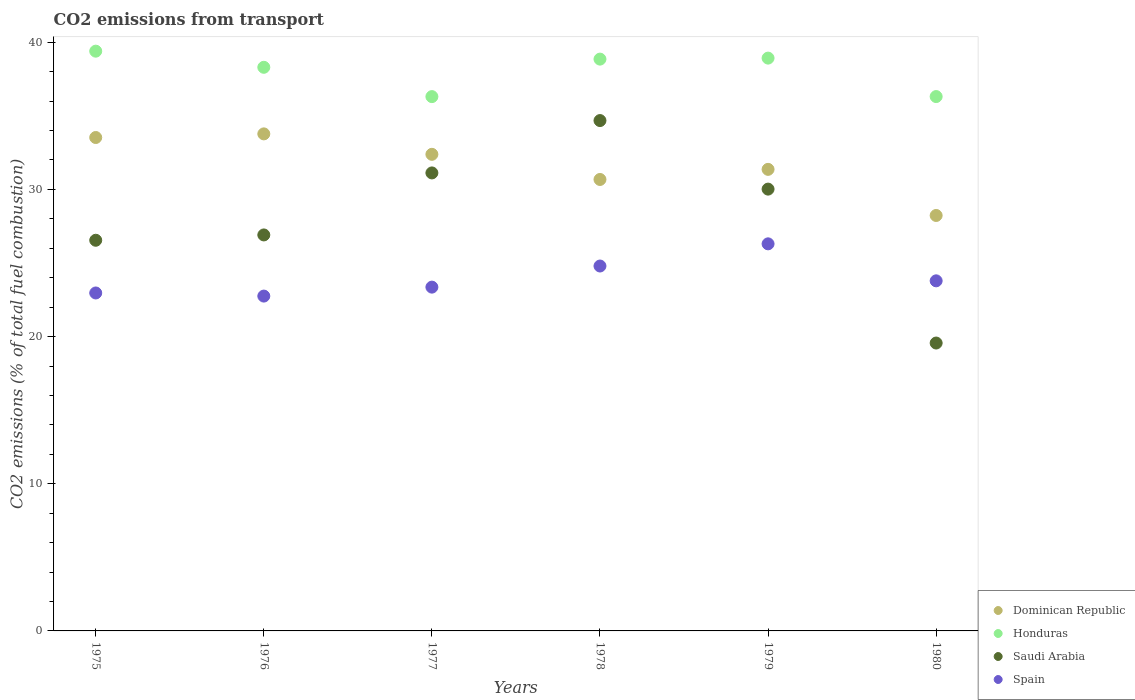How many different coloured dotlines are there?
Your response must be concise. 4. Is the number of dotlines equal to the number of legend labels?
Provide a succinct answer. Yes. What is the total CO2 emitted in Spain in 1975?
Provide a succinct answer. 22.96. Across all years, what is the maximum total CO2 emitted in Honduras?
Offer a very short reply. 39.39. Across all years, what is the minimum total CO2 emitted in Dominican Republic?
Ensure brevity in your answer.  28.23. In which year was the total CO2 emitted in Saudi Arabia maximum?
Offer a very short reply. 1978. In which year was the total CO2 emitted in Honduras minimum?
Provide a short and direct response. 1977. What is the total total CO2 emitted in Saudi Arabia in the graph?
Keep it short and to the point. 168.83. What is the difference between the total CO2 emitted in Honduras in 1976 and that in 1978?
Keep it short and to the point. -0.56. What is the difference between the total CO2 emitted in Honduras in 1980 and the total CO2 emitted in Saudi Arabia in 1977?
Your answer should be very brief. 5.19. What is the average total CO2 emitted in Spain per year?
Provide a succinct answer. 23.99. In the year 1979, what is the difference between the total CO2 emitted in Honduras and total CO2 emitted in Dominican Republic?
Your answer should be compact. 7.56. What is the ratio of the total CO2 emitted in Dominican Republic in 1975 to that in 1979?
Your response must be concise. 1.07. What is the difference between the highest and the second highest total CO2 emitted in Dominican Republic?
Make the answer very short. 0.25. What is the difference between the highest and the lowest total CO2 emitted in Honduras?
Offer a terse response. 3.09. Is it the case that in every year, the sum of the total CO2 emitted in Saudi Arabia and total CO2 emitted in Honduras  is greater than the total CO2 emitted in Dominican Republic?
Keep it short and to the point. Yes. Is the total CO2 emitted in Spain strictly greater than the total CO2 emitted in Dominican Republic over the years?
Give a very brief answer. No. Is the total CO2 emitted in Spain strictly less than the total CO2 emitted in Saudi Arabia over the years?
Keep it short and to the point. No. How many dotlines are there?
Your response must be concise. 4. How many years are there in the graph?
Your answer should be compact. 6. What is the difference between two consecutive major ticks on the Y-axis?
Give a very brief answer. 10. Are the values on the major ticks of Y-axis written in scientific E-notation?
Provide a short and direct response. No. Does the graph contain any zero values?
Your answer should be very brief. No. Does the graph contain grids?
Offer a terse response. No. Where does the legend appear in the graph?
Provide a short and direct response. Bottom right. How are the legend labels stacked?
Keep it short and to the point. Vertical. What is the title of the graph?
Keep it short and to the point. CO2 emissions from transport. Does "West Bank and Gaza" appear as one of the legend labels in the graph?
Offer a very short reply. No. What is the label or title of the X-axis?
Offer a very short reply. Years. What is the label or title of the Y-axis?
Provide a succinct answer. CO2 emissions (% of total fuel combustion). What is the CO2 emissions (% of total fuel combustion) in Dominican Republic in 1975?
Provide a short and direct response. 33.53. What is the CO2 emissions (% of total fuel combustion) of Honduras in 1975?
Offer a very short reply. 39.39. What is the CO2 emissions (% of total fuel combustion) of Saudi Arabia in 1975?
Offer a very short reply. 26.55. What is the CO2 emissions (% of total fuel combustion) in Spain in 1975?
Make the answer very short. 22.96. What is the CO2 emissions (% of total fuel combustion) of Dominican Republic in 1976?
Your answer should be compact. 33.77. What is the CO2 emissions (% of total fuel combustion) in Honduras in 1976?
Provide a succinct answer. 38.3. What is the CO2 emissions (% of total fuel combustion) in Saudi Arabia in 1976?
Offer a terse response. 26.91. What is the CO2 emissions (% of total fuel combustion) in Spain in 1976?
Offer a terse response. 22.75. What is the CO2 emissions (% of total fuel combustion) of Dominican Republic in 1977?
Make the answer very short. 32.38. What is the CO2 emissions (% of total fuel combustion) of Honduras in 1977?
Your response must be concise. 36.31. What is the CO2 emissions (% of total fuel combustion) of Saudi Arabia in 1977?
Your response must be concise. 31.12. What is the CO2 emissions (% of total fuel combustion) in Spain in 1977?
Give a very brief answer. 23.36. What is the CO2 emissions (% of total fuel combustion) of Dominican Republic in 1978?
Your response must be concise. 30.68. What is the CO2 emissions (% of total fuel combustion) in Honduras in 1978?
Keep it short and to the point. 38.85. What is the CO2 emissions (% of total fuel combustion) of Saudi Arabia in 1978?
Your answer should be very brief. 34.68. What is the CO2 emissions (% of total fuel combustion) of Spain in 1978?
Your answer should be compact. 24.8. What is the CO2 emissions (% of total fuel combustion) of Dominican Republic in 1979?
Provide a succinct answer. 31.36. What is the CO2 emissions (% of total fuel combustion) of Honduras in 1979?
Your response must be concise. 38.92. What is the CO2 emissions (% of total fuel combustion) of Saudi Arabia in 1979?
Your answer should be compact. 30.02. What is the CO2 emissions (% of total fuel combustion) of Spain in 1979?
Ensure brevity in your answer.  26.3. What is the CO2 emissions (% of total fuel combustion) of Dominican Republic in 1980?
Ensure brevity in your answer.  28.23. What is the CO2 emissions (% of total fuel combustion) in Honduras in 1980?
Keep it short and to the point. 36.31. What is the CO2 emissions (% of total fuel combustion) of Saudi Arabia in 1980?
Offer a very short reply. 19.56. What is the CO2 emissions (% of total fuel combustion) in Spain in 1980?
Your response must be concise. 23.79. Across all years, what is the maximum CO2 emissions (% of total fuel combustion) in Dominican Republic?
Provide a short and direct response. 33.77. Across all years, what is the maximum CO2 emissions (% of total fuel combustion) of Honduras?
Keep it short and to the point. 39.39. Across all years, what is the maximum CO2 emissions (% of total fuel combustion) in Saudi Arabia?
Give a very brief answer. 34.68. Across all years, what is the maximum CO2 emissions (% of total fuel combustion) in Spain?
Provide a short and direct response. 26.3. Across all years, what is the minimum CO2 emissions (% of total fuel combustion) of Dominican Republic?
Ensure brevity in your answer.  28.23. Across all years, what is the minimum CO2 emissions (% of total fuel combustion) of Honduras?
Your answer should be very brief. 36.31. Across all years, what is the minimum CO2 emissions (% of total fuel combustion) of Saudi Arabia?
Your answer should be compact. 19.56. Across all years, what is the minimum CO2 emissions (% of total fuel combustion) in Spain?
Your answer should be compact. 22.75. What is the total CO2 emissions (% of total fuel combustion) in Dominican Republic in the graph?
Provide a succinct answer. 189.95. What is the total CO2 emissions (% of total fuel combustion) in Honduras in the graph?
Offer a very short reply. 228.08. What is the total CO2 emissions (% of total fuel combustion) in Saudi Arabia in the graph?
Ensure brevity in your answer.  168.83. What is the total CO2 emissions (% of total fuel combustion) of Spain in the graph?
Your response must be concise. 143.96. What is the difference between the CO2 emissions (% of total fuel combustion) in Dominican Republic in 1975 and that in 1976?
Your answer should be very brief. -0.25. What is the difference between the CO2 emissions (% of total fuel combustion) in Honduras in 1975 and that in 1976?
Ensure brevity in your answer.  1.1. What is the difference between the CO2 emissions (% of total fuel combustion) in Saudi Arabia in 1975 and that in 1976?
Make the answer very short. -0.36. What is the difference between the CO2 emissions (% of total fuel combustion) in Spain in 1975 and that in 1976?
Offer a very short reply. 0.21. What is the difference between the CO2 emissions (% of total fuel combustion) in Dominican Republic in 1975 and that in 1977?
Your answer should be very brief. 1.14. What is the difference between the CO2 emissions (% of total fuel combustion) of Honduras in 1975 and that in 1977?
Provide a succinct answer. 3.09. What is the difference between the CO2 emissions (% of total fuel combustion) of Saudi Arabia in 1975 and that in 1977?
Give a very brief answer. -4.58. What is the difference between the CO2 emissions (% of total fuel combustion) of Spain in 1975 and that in 1977?
Provide a short and direct response. -0.4. What is the difference between the CO2 emissions (% of total fuel combustion) in Dominican Republic in 1975 and that in 1978?
Keep it short and to the point. 2.85. What is the difference between the CO2 emissions (% of total fuel combustion) of Honduras in 1975 and that in 1978?
Your response must be concise. 0.54. What is the difference between the CO2 emissions (% of total fuel combustion) in Saudi Arabia in 1975 and that in 1978?
Your answer should be very brief. -8.13. What is the difference between the CO2 emissions (% of total fuel combustion) of Spain in 1975 and that in 1978?
Offer a terse response. -1.83. What is the difference between the CO2 emissions (% of total fuel combustion) in Dominican Republic in 1975 and that in 1979?
Make the answer very short. 2.16. What is the difference between the CO2 emissions (% of total fuel combustion) in Honduras in 1975 and that in 1979?
Your answer should be compact. 0.47. What is the difference between the CO2 emissions (% of total fuel combustion) of Saudi Arabia in 1975 and that in 1979?
Your response must be concise. -3.48. What is the difference between the CO2 emissions (% of total fuel combustion) in Spain in 1975 and that in 1979?
Your answer should be very brief. -3.34. What is the difference between the CO2 emissions (% of total fuel combustion) in Dominican Republic in 1975 and that in 1980?
Keep it short and to the point. 5.3. What is the difference between the CO2 emissions (% of total fuel combustion) in Honduras in 1975 and that in 1980?
Offer a terse response. 3.08. What is the difference between the CO2 emissions (% of total fuel combustion) of Saudi Arabia in 1975 and that in 1980?
Make the answer very short. 6.98. What is the difference between the CO2 emissions (% of total fuel combustion) of Spain in 1975 and that in 1980?
Offer a very short reply. -0.82. What is the difference between the CO2 emissions (% of total fuel combustion) in Dominican Republic in 1976 and that in 1977?
Give a very brief answer. 1.39. What is the difference between the CO2 emissions (% of total fuel combustion) in Honduras in 1976 and that in 1977?
Your response must be concise. 1.99. What is the difference between the CO2 emissions (% of total fuel combustion) in Saudi Arabia in 1976 and that in 1977?
Your answer should be very brief. -4.21. What is the difference between the CO2 emissions (% of total fuel combustion) of Spain in 1976 and that in 1977?
Keep it short and to the point. -0.61. What is the difference between the CO2 emissions (% of total fuel combustion) of Dominican Republic in 1976 and that in 1978?
Give a very brief answer. 3.1. What is the difference between the CO2 emissions (% of total fuel combustion) in Honduras in 1976 and that in 1978?
Your response must be concise. -0.56. What is the difference between the CO2 emissions (% of total fuel combustion) in Saudi Arabia in 1976 and that in 1978?
Provide a short and direct response. -7.77. What is the difference between the CO2 emissions (% of total fuel combustion) of Spain in 1976 and that in 1978?
Offer a terse response. -2.04. What is the difference between the CO2 emissions (% of total fuel combustion) in Dominican Republic in 1976 and that in 1979?
Keep it short and to the point. 2.41. What is the difference between the CO2 emissions (% of total fuel combustion) in Honduras in 1976 and that in 1979?
Offer a terse response. -0.62. What is the difference between the CO2 emissions (% of total fuel combustion) of Saudi Arabia in 1976 and that in 1979?
Keep it short and to the point. -3.11. What is the difference between the CO2 emissions (% of total fuel combustion) in Spain in 1976 and that in 1979?
Your response must be concise. -3.55. What is the difference between the CO2 emissions (% of total fuel combustion) of Dominican Republic in 1976 and that in 1980?
Provide a short and direct response. 5.54. What is the difference between the CO2 emissions (% of total fuel combustion) of Honduras in 1976 and that in 1980?
Your response must be concise. 1.99. What is the difference between the CO2 emissions (% of total fuel combustion) in Saudi Arabia in 1976 and that in 1980?
Keep it short and to the point. 7.35. What is the difference between the CO2 emissions (% of total fuel combustion) of Spain in 1976 and that in 1980?
Give a very brief answer. -1.04. What is the difference between the CO2 emissions (% of total fuel combustion) of Dominican Republic in 1977 and that in 1978?
Provide a succinct answer. 1.71. What is the difference between the CO2 emissions (% of total fuel combustion) of Honduras in 1977 and that in 1978?
Provide a succinct answer. -2.55. What is the difference between the CO2 emissions (% of total fuel combustion) of Saudi Arabia in 1977 and that in 1978?
Your answer should be very brief. -3.56. What is the difference between the CO2 emissions (% of total fuel combustion) in Spain in 1977 and that in 1978?
Your answer should be very brief. -1.43. What is the difference between the CO2 emissions (% of total fuel combustion) of Dominican Republic in 1977 and that in 1979?
Provide a succinct answer. 1.02. What is the difference between the CO2 emissions (% of total fuel combustion) of Honduras in 1977 and that in 1979?
Keep it short and to the point. -2.62. What is the difference between the CO2 emissions (% of total fuel combustion) of Saudi Arabia in 1977 and that in 1979?
Provide a succinct answer. 1.1. What is the difference between the CO2 emissions (% of total fuel combustion) of Spain in 1977 and that in 1979?
Your answer should be compact. -2.94. What is the difference between the CO2 emissions (% of total fuel combustion) in Dominican Republic in 1977 and that in 1980?
Make the answer very short. 4.15. What is the difference between the CO2 emissions (% of total fuel combustion) in Honduras in 1977 and that in 1980?
Your answer should be very brief. -0. What is the difference between the CO2 emissions (% of total fuel combustion) of Saudi Arabia in 1977 and that in 1980?
Offer a terse response. 11.56. What is the difference between the CO2 emissions (% of total fuel combustion) in Spain in 1977 and that in 1980?
Offer a very short reply. -0.43. What is the difference between the CO2 emissions (% of total fuel combustion) in Dominican Republic in 1978 and that in 1979?
Your answer should be very brief. -0.69. What is the difference between the CO2 emissions (% of total fuel combustion) of Honduras in 1978 and that in 1979?
Offer a terse response. -0.07. What is the difference between the CO2 emissions (% of total fuel combustion) in Saudi Arabia in 1978 and that in 1979?
Keep it short and to the point. 4.66. What is the difference between the CO2 emissions (% of total fuel combustion) of Spain in 1978 and that in 1979?
Ensure brevity in your answer.  -1.51. What is the difference between the CO2 emissions (% of total fuel combustion) of Dominican Republic in 1978 and that in 1980?
Offer a terse response. 2.45. What is the difference between the CO2 emissions (% of total fuel combustion) of Honduras in 1978 and that in 1980?
Offer a very short reply. 2.54. What is the difference between the CO2 emissions (% of total fuel combustion) in Saudi Arabia in 1978 and that in 1980?
Your response must be concise. 15.12. What is the difference between the CO2 emissions (% of total fuel combustion) of Spain in 1978 and that in 1980?
Provide a short and direct response. 1.01. What is the difference between the CO2 emissions (% of total fuel combustion) of Dominican Republic in 1979 and that in 1980?
Your response must be concise. 3.13. What is the difference between the CO2 emissions (% of total fuel combustion) of Honduras in 1979 and that in 1980?
Provide a short and direct response. 2.61. What is the difference between the CO2 emissions (% of total fuel combustion) of Saudi Arabia in 1979 and that in 1980?
Offer a very short reply. 10.46. What is the difference between the CO2 emissions (% of total fuel combustion) of Spain in 1979 and that in 1980?
Give a very brief answer. 2.51. What is the difference between the CO2 emissions (% of total fuel combustion) of Dominican Republic in 1975 and the CO2 emissions (% of total fuel combustion) of Honduras in 1976?
Provide a succinct answer. -4.77. What is the difference between the CO2 emissions (% of total fuel combustion) of Dominican Republic in 1975 and the CO2 emissions (% of total fuel combustion) of Saudi Arabia in 1976?
Ensure brevity in your answer.  6.62. What is the difference between the CO2 emissions (% of total fuel combustion) of Dominican Republic in 1975 and the CO2 emissions (% of total fuel combustion) of Spain in 1976?
Give a very brief answer. 10.78. What is the difference between the CO2 emissions (% of total fuel combustion) of Honduras in 1975 and the CO2 emissions (% of total fuel combustion) of Saudi Arabia in 1976?
Provide a succinct answer. 12.49. What is the difference between the CO2 emissions (% of total fuel combustion) of Honduras in 1975 and the CO2 emissions (% of total fuel combustion) of Spain in 1976?
Give a very brief answer. 16.64. What is the difference between the CO2 emissions (% of total fuel combustion) of Saudi Arabia in 1975 and the CO2 emissions (% of total fuel combustion) of Spain in 1976?
Keep it short and to the point. 3.79. What is the difference between the CO2 emissions (% of total fuel combustion) of Dominican Republic in 1975 and the CO2 emissions (% of total fuel combustion) of Honduras in 1977?
Give a very brief answer. -2.78. What is the difference between the CO2 emissions (% of total fuel combustion) in Dominican Republic in 1975 and the CO2 emissions (% of total fuel combustion) in Saudi Arabia in 1977?
Provide a succinct answer. 2.41. What is the difference between the CO2 emissions (% of total fuel combustion) in Dominican Republic in 1975 and the CO2 emissions (% of total fuel combustion) in Spain in 1977?
Your answer should be compact. 10.17. What is the difference between the CO2 emissions (% of total fuel combustion) of Honduras in 1975 and the CO2 emissions (% of total fuel combustion) of Saudi Arabia in 1977?
Your response must be concise. 8.27. What is the difference between the CO2 emissions (% of total fuel combustion) of Honduras in 1975 and the CO2 emissions (% of total fuel combustion) of Spain in 1977?
Your response must be concise. 16.03. What is the difference between the CO2 emissions (% of total fuel combustion) of Saudi Arabia in 1975 and the CO2 emissions (% of total fuel combustion) of Spain in 1977?
Offer a very short reply. 3.18. What is the difference between the CO2 emissions (% of total fuel combustion) of Dominican Republic in 1975 and the CO2 emissions (% of total fuel combustion) of Honduras in 1978?
Give a very brief answer. -5.33. What is the difference between the CO2 emissions (% of total fuel combustion) of Dominican Republic in 1975 and the CO2 emissions (% of total fuel combustion) of Saudi Arabia in 1978?
Keep it short and to the point. -1.15. What is the difference between the CO2 emissions (% of total fuel combustion) in Dominican Republic in 1975 and the CO2 emissions (% of total fuel combustion) in Spain in 1978?
Your answer should be very brief. 8.73. What is the difference between the CO2 emissions (% of total fuel combustion) in Honduras in 1975 and the CO2 emissions (% of total fuel combustion) in Saudi Arabia in 1978?
Offer a very short reply. 4.72. What is the difference between the CO2 emissions (% of total fuel combustion) of Honduras in 1975 and the CO2 emissions (% of total fuel combustion) of Spain in 1978?
Keep it short and to the point. 14.6. What is the difference between the CO2 emissions (% of total fuel combustion) of Saudi Arabia in 1975 and the CO2 emissions (% of total fuel combustion) of Spain in 1978?
Give a very brief answer. 1.75. What is the difference between the CO2 emissions (% of total fuel combustion) of Dominican Republic in 1975 and the CO2 emissions (% of total fuel combustion) of Honduras in 1979?
Provide a short and direct response. -5.39. What is the difference between the CO2 emissions (% of total fuel combustion) in Dominican Republic in 1975 and the CO2 emissions (% of total fuel combustion) in Saudi Arabia in 1979?
Offer a terse response. 3.51. What is the difference between the CO2 emissions (% of total fuel combustion) of Dominican Republic in 1975 and the CO2 emissions (% of total fuel combustion) of Spain in 1979?
Keep it short and to the point. 7.23. What is the difference between the CO2 emissions (% of total fuel combustion) of Honduras in 1975 and the CO2 emissions (% of total fuel combustion) of Saudi Arabia in 1979?
Your response must be concise. 9.37. What is the difference between the CO2 emissions (% of total fuel combustion) of Honduras in 1975 and the CO2 emissions (% of total fuel combustion) of Spain in 1979?
Ensure brevity in your answer.  13.09. What is the difference between the CO2 emissions (% of total fuel combustion) in Saudi Arabia in 1975 and the CO2 emissions (% of total fuel combustion) in Spain in 1979?
Provide a succinct answer. 0.24. What is the difference between the CO2 emissions (% of total fuel combustion) of Dominican Republic in 1975 and the CO2 emissions (% of total fuel combustion) of Honduras in 1980?
Keep it short and to the point. -2.78. What is the difference between the CO2 emissions (% of total fuel combustion) in Dominican Republic in 1975 and the CO2 emissions (% of total fuel combustion) in Saudi Arabia in 1980?
Your answer should be compact. 13.97. What is the difference between the CO2 emissions (% of total fuel combustion) of Dominican Republic in 1975 and the CO2 emissions (% of total fuel combustion) of Spain in 1980?
Offer a very short reply. 9.74. What is the difference between the CO2 emissions (% of total fuel combustion) in Honduras in 1975 and the CO2 emissions (% of total fuel combustion) in Saudi Arabia in 1980?
Ensure brevity in your answer.  19.83. What is the difference between the CO2 emissions (% of total fuel combustion) of Honduras in 1975 and the CO2 emissions (% of total fuel combustion) of Spain in 1980?
Your response must be concise. 15.61. What is the difference between the CO2 emissions (% of total fuel combustion) in Saudi Arabia in 1975 and the CO2 emissions (% of total fuel combustion) in Spain in 1980?
Offer a terse response. 2.76. What is the difference between the CO2 emissions (% of total fuel combustion) of Dominican Republic in 1976 and the CO2 emissions (% of total fuel combustion) of Honduras in 1977?
Make the answer very short. -2.53. What is the difference between the CO2 emissions (% of total fuel combustion) of Dominican Republic in 1976 and the CO2 emissions (% of total fuel combustion) of Saudi Arabia in 1977?
Make the answer very short. 2.65. What is the difference between the CO2 emissions (% of total fuel combustion) in Dominican Republic in 1976 and the CO2 emissions (% of total fuel combustion) in Spain in 1977?
Offer a very short reply. 10.41. What is the difference between the CO2 emissions (% of total fuel combustion) in Honduras in 1976 and the CO2 emissions (% of total fuel combustion) in Saudi Arabia in 1977?
Provide a short and direct response. 7.18. What is the difference between the CO2 emissions (% of total fuel combustion) of Honduras in 1976 and the CO2 emissions (% of total fuel combustion) of Spain in 1977?
Your response must be concise. 14.94. What is the difference between the CO2 emissions (% of total fuel combustion) in Saudi Arabia in 1976 and the CO2 emissions (% of total fuel combustion) in Spain in 1977?
Offer a terse response. 3.55. What is the difference between the CO2 emissions (% of total fuel combustion) in Dominican Republic in 1976 and the CO2 emissions (% of total fuel combustion) in Honduras in 1978?
Offer a very short reply. -5.08. What is the difference between the CO2 emissions (% of total fuel combustion) of Dominican Republic in 1976 and the CO2 emissions (% of total fuel combustion) of Saudi Arabia in 1978?
Your answer should be compact. -0.9. What is the difference between the CO2 emissions (% of total fuel combustion) of Dominican Republic in 1976 and the CO2 emissions (% of total fuel combustion) of Spain in 1978?
Provide a short and direct response. 8.98. What is the difference between the CO2 emissions (% of total fuel combustion) in Honduras in 1976 and the CO2 emissions (% of total fuel combustion) in Saudi Arabia in 1978?
Offer a terse response. 3.62. What is the difference between the CO2 emissions (% of total fuel combustion) in Honduras in 1976 and the CO2 emissions (% of total fuel combustion) in Spain in 1978?
Offer a very short reply. 13.5. What is the difference between the CO2 emissions (% of total fuel combustion) of Saudi Arabia in 1976 and the CO2 emissions (% of total fuel combustion) of Spain in 1978?
Offer a very short reply. 2.11. What is the difference between the CO2 emissions (% of total fuel combustion) in Dominican Republic in 1976 and the CO2 emissions (% of total fuel combustion) in Honduras in 1979?
Keep it short and to the point. -5.15. What is the difference between the CO2 emissions (% of total fuel combustion) of Dominican Republic in 1976 and the CO2 emissions (% of total fuel combustion) of Saudi Arabia in 1979?
Offer a very short reply. 3.75. What is the difference between the CO2 emissions (% of total fuel combustion) in Dominican Republic in 1976 and the CO2 emissions (% of total fuel combustion) in Spain in 1979?
Give a very brief answer. 7.47. What is the difference between the CO2 emissions (% of total fuel combustion) of Honduras in 1976 and the CO2 emissions (% of total fuel combustion) of Saudi Arabia in 1979?
Give a very brief answer. 8.28. What is the difference between the CO2 emissions (% of total fuel combustion) in Honduras in 1976 and the CO2 emissions (% of total fuel combustion) in Spain in 1979?
Ensure brevity in your answer.  12. What is the difference between the CO2 emissions (% of total fuel combustion) of Saudi Arabia in 1976 and the CO2 emissions (% of total fuel combustion) of Spain in 1979?
Give a very brief answer. 0.61. What is the difference between the CO2 emissions (% of total fuel combustion) in Dominican Republic in 1976 and the CO2 emissions (% of total fuel combustion) in Honduras in 1980?
Your response must be concise. -2.54. What is the difference between the CO2 emissions (% of total fuel combustion) in Dominican Republic in 1976 and the CO2 emissions (% of total fuel combustion) in Saudi Arabia in 1980?
Your answer should be very brief. 14.21. What is the difference between the CO2 emissions (% of total fuel combustion) in Dominican Republic in 1976 and the CO2 emissions (% of total fuel combustion) in Spain in 1980?
Your response must be concise. 9.99. What is the difference between the CO2 emissions (% of total fuel combustion) of Honduras in 1976 and the CO2 emissions (% of total fuel combustion) of Saudi Arabia in 1980?
Give a very brief answer. 18.74. What is the difference between the CO2 emissions (% of total fuel combustion) in Honduras in 1976 and the CO2 emissions (% of total fuel combustion) in Spain in 1980?
Give a very brief answer. 14.51. What is the difference between the CO2 emissions (% of total fuel combustion) of Saudi Arabia in 1976 and the CO2 emissions (% of total fuel combustion) of Spain in 1980?
Provide a succinct answer. 3.12. What is the difference between the CO2 emissions (% of total fuel combustion) in Dominican Republic in 1977 and the CO2 emissions (% of total fuel combustion) in Honduras in 1978?
Provide a short and direct response. -6.47. What is the difference between the CO2 emissions (% of total fuel combustion) of Dominican Republic in 1977 and the CO2 emissions (% of total fuel combustion) of Saudi Arabia in 1978?
Provide a short and direct response. -2.29. What is the difference between the CO2 emissions (% of total fuel combustion) of Dominican Republic in 1977 and the CO2 emissions (% of total fuel combustion) of Spain in 1978?
Provide a short and direct response. 7.59. What is the difference between the CO2 emissions (% of total fuel combustion) in Honduras in 1977 and the CO2 emissions (% of total fuel combustion) in Saudi Arabia in 1978?
Your answer should be very brief. 1.63. What is the difference between the CO2 emissions (% of total fuel combustion) in Honduras in 1977 and the CO2 emissions (% of total fuel combustion) in Spain in 1978?
Your answer should be very brief. 11.51. What is the difference between the CO2 emissions (% of total fuel combustion) of Saudi Arabia in 1977 and the CO2 emissions (% of total fuel combustion) of Spain in 1978?
Your answer should be compact. 6.33. What is the difference between the CO2 emissions (% of total fuel combustion) of Dominican Republic in 1977 and the CO2 emissions (% of total fuel combustion) of Honduras in 1979?
Offer a very short reply. -6.54. What is the difference between the CO2 emissions (% of total fuel combustion) of Dominican Republic in 1977 and the CO2 emissions (% of total fuel combustion) of Saudi Arabia in 1979?
Your response must be concise. 2.36. What is the difference between the CO2 emissions (% of total fuel combustion) in Dominican Republic in 1977 and the CO2 emissions (% of total fuel combustion) in Spain in 1979?
Your response must be concise. 6.08. What is the difference between the CO2 emissions (% of total fuel combustion) of Honduras in 1977 and the CO2 emissions (% of total fuel combustion) of Saudi Arabia in 1979?
Keep it short and to the point. 6.29. What is the difference between the CO2 emissions (% of total fuel combustion) of Honduras in 1977 and the CO2 emissions (% of total fuel combustion) of Spain in 1979?
Provide a succinct answer. 10. What is the difference between the CO2 emissions (% of total fuel combustion) in Saudi Arabia in 1977 and the CO2 emissions (% of total fuel combustion) in Spain in 1979?
Ensure brevity in your answer.  4.82. What is the difference between the CO2 emissions (% of total fuel combustion) in Dominican Republic in 1977 and the CO2 emissions (% of total fuel combustion) in Honduras in 1980?
Offer a terse response. -3.93. What is the difference between the CO2 emissions (% of total fuel combustion) of Dominican Republic in 1977 and the CO2 emissions (% of total fuel combustion) of Saudi Arabia in 1980?
Make the answer very short. 12.82. What is the difference between the CO2 emissions (% of total fuel combustion) in Dominican Republic in 1977 and the CO2 emissions (% of total fuel combustion) in Spain in 1980?
Your response must be concise. 8.6. What is the difference between the CO2 emissions (% of total fuel combustion) in Honduras in 1977 and the CO2 emissions (% of total fuel combustion) in Saudi Arabia in 1980?
Offer a terse response. 16.74. What is the difference between the CO2 emissions (% of total fuel combustion) of Honduras in 1977 and the CO2 emissions (% of total fuel combustion) of Spain in 1980?
Provide a short and direct response. 12.52. What is the difference between the CO2 emissions (% of total fuel combustion) in Saudi Arabia in 1977 and the CO2 emissions (% of total fuel combustion) in Spain in 1980?
Your answer should be very brief. 7.33. What is the difference between the CO2 emissions (% of total fuel combustion) in Dominican Republic in 1978 and the CO2 emissions (% of total fuel combustion) in Honduras in 1979?
Give a very brief answer. -8.25. What is the difference between the CO2 emissions (% of total fuel combustion) of Dominican Republic in 1978 and the CO2 emissions (% of total fuel combustion) of Saudi Arabia in 1979?
Your answer should be compact. 0.66. What is the difference between the CO2 emissions (% of total fuel combustion) of Dominican Republic in 1978 and the CO2 emissions (% of total fuel combustion) of Spain in 1979?
Ensure brevity in your answer.  4.37. What is the difference between the CO2 emissions (% of total fuel combustion) of Honduras in 1978 and the CO2 emissions (% of total fuel combustion) of Saudi Arabia in 1979?
Provide a succinct answer. 8.83. What is the difference between the CO2 emissions (% of total fuel combustion) of Honduras in 1978 and the CO2 emissions (% of total fuel combustion) of Spain in 1979?
Your answer should be compact. 12.55. What is the difference between the CO2 emissions (% of total fuel combustion) in Saudi Arabia in 1978 and the CO2 emissions (% of total fuel combustion) in Spain in 1979?
Your answer should be compact. 8.38. What is the difference between the CO2 emissions (% of total fuel combustion) of Dominican Republic in 1978 and the CO2 emissions (% of total fuel combustion) of Honduras in 1980?
Keep it short and to the point. -5.63. What is the difference between the CO2 emissions (% of total fuel combustion) of Dominican Republic in 1978 and the CO2 emissions (% of total fuel combustion) of Saudi Arabia in 1980?
Provide a succinct answer. 11.11. What is the difference between the CO2 emissions (% of total fuel combustion) of Dominican Republic in 1978 and the CO2 emissions (% of total fuel combustion) of Spain in 1980?
Your response must be concise. 6.89. What is the difference between the CO2 emissions (% of total fuel combustion) of Honduras in 1978 and the CO2 emissions (% of total fuel combustion) of Saudi Arabia in 1980?
Your answer should be very brief. 19.29. What is the difference between the CO2 emissions (% of total fuel combustion) in Honduras in 1978 and the CO2 emissions (% of total fuel combustion) in Spain in 1980?
Provide a succinct answer. 15.07. What is the difference between the CO2 emissions (% of total fuel combustion) in Saudi Arabia in 1978 and the CO2 emissions (% of total fuel combustion) in Spain in 1980?
Offer a terse response. 10.89. What is the difference between the CO2 emissions (% of total fuel combustion) in Dominican Republic in 1979 and the CO2 emissions (% of total fuel combustion) in Honduras in 1980?
Make the answer very short. -4.95. What is the difference between the CO2 emissions (% of total fuel combustion) of Dominican Republic in 1979 and the CO2 emissions (% of total fuel combustion) of Saudi Arabia in 1980?
Your answer should be compact. 11.8. What is the difference between the CO2 emissions (% of total fuel combustion) of Dominican Republic in 1979 and the CO2 emissions (% of total fuel combustion) of Spain in 1980?
Provide a succinct answer. 7.57. What is the difference between the CO2 emissions (% of total fuel combustion) of Honduras in 1979 and the CO2 emissions (% of total fuel combustion) of Saudi Arabia in 1980?
Make the answer very short. 19.36. What is the difference between the CO2 emissions (% of total fuel combustion) in Honduras in 1979 and the CO2 emissions (% of total fuel combustion) in Spain in 1980?
Your answer should be very brief. 15.13. What is the difference between the CO2 emissions (% of total fuel combustion) in Saudi Arabia in 1979 and the CO2 emissions (% of total fuel combustion) in Spain in 1980?
Give a very brief answer. 6.23. What is the average CO2 emissions (% of total fuel combustion) of Dominican Republic per year?
Make the answer very short. 31.66. What is the average CO2 emissions (% of total fuel combustion) of Honduras per year?
Your response must be concise. 38.01. What is the average CO2 emissions (% of total fuel combustion) of Saudi Arabia per year?
Offer a terse response. 28.14. What is the average CO2 emissions (% of total fuel combustion) in Spain per year?
Ensure brevity in your answer.  23.99. In the year 1975, what is the difference between the CO2 emissions (% of total fuel combustion) of Dominican Republic and CO2 emissions (% of total fuel combustion) of Honduras?
Give a very brief answer. -5.87. In the year 1975, what is the difference between the CO2 emissions (% of total fuel combustion) of Dominican Republic and CO2 emissions (% of total fuel combustion) of Saudi Arabia?
Provide a short and direct response. 6.98. In the year 1975, what is the difference between the CO2 emissions (% of total fuel combustion) in Dominican Republic and CO2 emissions (% of total fuel combustion) in Spain?
Provide a succinct answer. 10.56. In the year 1975, what is the difference between the CO2 emissions (% of total fuel combustion) of Honduras and CO2 emissions (% of total fuel combustion) of Saudi Arabia?
Keep it short and to the point. 12.85. In the year 1975, what is the difference between the CO2 emissions (% of total fuel combustion) in Honduras and CO2 emissions (% of total fuel combustion) in Spain?
Your answer should be compact. 16.43. In the year 1975, what is the difference between the CO2 emissions (% of total fuel combustion) of Saudi Arabia and CO2 emissions (% of total fuel combustion) of Spain?
Make the answer very short. 3.58. In the year 1976, what is the difference between the CO2 emissions (% of total fuel combustion) of Dominican Republic and CO2 emissions (% of total fuel combustion) of Honduras?
Your answer should be very brief. -4.52. In the year 1976, what is the difference between the CO2 emissions (% of total fuel combustion) of Dominican Republic and CO2 emissions (% of total fuel combustion) of Saudi Arabia?
Ensure brevity in your answer.  6.87. In the year 1976, what is the difference between the CO2 emissions (% of total fuel combustion) in Dominican Republic and CO2 emissions (% of total fuel combustion) in Spain?
Offer a terse response. 11.02. In the year 1976, what is the difference between the CO2 emissions (% of total fuel combustion) of Honduras and CO2 emissions (% of total fuel combustion) of Saudi Arabia?
Your answer should be compact. 11.39. In the year 1976, what is the difference between the CO2 emissions (% of total fuel combustion) of Honduras and CO2 emissions (% of total fuel combustion) of Spain?
Provide a short and direct response. 15.55. In the year 1976, what is the difference between the CO2 emissions (% of total fuel combustion) in Saudi Arabia and CO2 emissions (% of total fuel combustion) in Spain?
Your answer should be very brief. 4.15. In the year 1977, what is the difference between the CO2 emissions (% of total fuel combustion) in Dominican Republic and CO2 emissions (% of total fuel combustion) in Honduras?
Your answer should be compact. -3.92. In the year 1977, what is the difference between the CO2 emissions (% of total fuel combustion) of Dominican Republic and CO2 emissions (% of total fuel combustion) of Saudi Arabia?
Offer a very short reply. 1.26. In the year 1977, what is the difference between the CO2 emissions (% of total fuel combustion) of Dominican Republic and CO2 emissions (% of total fuel combustion) of Spain?
Offer a very short reply. 9.02. In the year 1977, what is the difference between the CO2 emissions (% of total fuel combustion) in Honduras and CO2 emissions (% of total fuel combustion) in Saudi Arabia?
Your answer should be compact. 5.18. In the year 1977, what is the difference between the CO2 emissions (% of total fuel combustion) in Honduras and CO2 emissions (% of total fuel combustion) in Spain?
Make the answer very short. 12.95. In the year 1977, what is the difference between the CO2 emissions (% of total fuel combustion) in Saudi Arabia and CO2 emissions (% of total fuel combustion) in Spain?
Keep it short and to the point. 7.76. In the year 1978, what is the difference between the CO2 emissions (% of total fuel combustion) in Dominican Republic and CO2 emissions (% of total fuel combustion) in Honduras?
Give a very brief answer. -8.18. In the year 1978, what is the difference between the CO2 emissions (% of total fuel combustion) in Dominican Republic and CO2 emissions (% of total fuel combustion) in Saudi Arabia?
Make the answer very short. -4. In the year 1978, what is the difference between the CO2 emissions (% of total fuel combustion) of Dominican Republic and CO2 emissions (% of total fuel combustion) of Spain?
Keep it short and to the point. 5.88. In the year 1978, what is the difference between the CO2 emissions (% of total fuel combustion) in Honduras and CO2 emissions (% of total fuel combustion) in Saudi Arabia?
Offer a terse response. 4.17. In the year 1978, what is the difference between the CO2 emissions (% of total fuel combustion) of Honduras and CO2 emissions (% of total fuel combustion) of Spain?
Provide a short and direct response. 14.06. In the year 1978, what is the difference between the CO2 emissions (% of total fuel combustion) in Saudi Arabia and CO2 emissions (% of total fuel combustion) in Spain?
Give a very brief answer. 9.88. In the year 1979, what is the difference between the CO2 emissions (% of total fuel combustion) of Dominican Republic and CO2 emissions (% of total fuel combustion) of Honduras?
Keep it short and to the point. -7.56. In the year 1979, what is the difference between the CO2 emissions (% of total fuel combustion) of Dominican Republic and CO2 emissions (% of total fuel combustion) of Saudi Arabia?
Offer a terse response. 1.34. In the year 1979, what is the difference between the CO2 emissions (% of total fuel combustion) of Dominican Republic and CO2 emissions (% of total fuel combustion) of Spain?
Your response must be concise. 5.06. In the year 1979, what is the difference between the CO2 emissions (% of total fuel combustion) of Honduras and CO2 emissions (% of total fuel combustion) of Saudi Arabia?
Offer a very short reply. 8.9. In the year 1979, what is the difference between the CO2 emissions (% of total fuel combustion) of Honduras and CO2 emissions (% of total fuel combustion) of Spain?
Provide a succinct answer. 12.62. In the year 1979, what is the difference between the CO2 emissions (% of total fuel combustion) in Saudi Arabia and CO2 emissions (% of total fuel combustion) in Spain?
Make the answer very short. 3.72. In the year 1980, what is the difference between the CO2 emissions (% of total fuel combustion) of Dominican Republic and CO2 emissions (% of total fuel combustion) of Honduras?
Make the answer very short. -8.08. In the year 1980, what is the difference between the CO2 emissions (% of total fuel combustion) in Dominican Republic and CO2 emissions (% of total fuel combustion) in Saudi Arabia?
Ensure brevity in your answer.  8.67. In the year 1980, what is the difference between the CO2 emissions (% of total fuel combustion) of Dominican Republic and CO2 emissions (% of total fuel combustion) of Spain?
Offer a terse response. 4.44. In the year 1980, what is the difference between the CO2 emissions (% of total fuel combustion) in Honduras and CO2 emissions (% of total fuel combustion) in Saudi Arabia?
Make the answer very short. 16.75. In the year 1980, what is the difference between the CO2 emissions (% of total fuel combustion) in Honduras and CO2 emissions (% of total fuel combustion) in Spain?
Offer a terse response. 12.52. In the year 1980, what is the difference between the CO2 emissions (% of total fuel combustion) of Saudi Arabia and CO2 emissions (% of total fuel combustion) of Spain?
Your answer should be very brief. -4.23. What is the ratio of the CO2 emissions (% of total fuel combustion) in Honduras in 1975 to that in 1976?
Offer a very short reply. 1.03. What is the ratio of the CO2 emissions (% of total fuel combustion) of Saudi Arabia in 1975 to that in 1976?
Keep it short and to the point. 0.99. What is the ratio of the CO2 emissions (% of total fuel combustion) of Spain in 1975 to that in 1976?
Offer a very short reply. 1.01. What is the ratio of the CO2 emissions (% of total fuel combustion) of Dominican Republic in 1975 to that in 1977?
Your answer should be compact. 1.04. What is the ratio of the CO2 emissions (% of total fuel combustion) in Honduras in 1975 to that in 1977?
Make the answer very short. 1.09. What is the ratio of the CO2 emissions (% of total fuel combustion) in Saudi Arabia in 1975 to that in 1977?
Keep it short and to the point. 0.85. What is the ratio of the CO2 emissions (% of total fuel combustion) in Spain in 1975 to that in 1977?
Provide a short and direct response. 0.98. What is the ratio of the CO2 emissions (% of total fuel combustion) in Dominican Republic in 1975 to that in 1978?
Keep it short and to the point. 1.09. What is the ratio of the CO2 emissions (% of total fuel combustion) in Honduras in 1975 to that in 1978?
Keep it short and to the point. 1.01. What is the ratio of the CO2 emissions (% of total fuel combustion) in Saudi Arabia in 1975 to that in 1978?
Provide a succinct answer. 0.77. What is the ratio of the CO2 emissions (% of total fuel combustion) in Spain in 1975 to that in 1978?
Offer a very short reply. 0.93. What is the ratio of the CO2 emissions (% of total fuel combustion) in Dominican Republic in 1975 to that in 1979?
Offer a very short reply. 1.07. What is the ratio of the CO2 emissions (% of total fuel combustion) of Honduras in 1975 to that in 1979?
Make the answer very short. 1.01. What is the ratio of the CO2 emissions (% of total fuel combustion) in Saudi Arabia in 1975 to that in 1979?
Offer a very short reply. 0.88. What is the ratio of the CO2 emissions (% of total fuel combustion) in Spain in 1975 to that in 1979?
Ensure brevity in your answer.  0.87. What is the ratio of the CO2 emissions (% of total fuel combustion) in Dominican Republic in 1975 to that in 1980?
Your response must be concise. 1.19. What is the ratio of the CO2 emissions (% of total fuel combustion) in Honduras in 1975 to that in 1980?
Offer a terse response. 1.08. What is the ratio of the CO2 emissions (% of total fuel combustion) in Saudi Arabia in 1975 to that in 1980?
Provide a succinct answer. 1.36. What is the ratio of the CO2 emissions (% of total fuel combustion) in Spain in 1975 to that in 1980?
Your answer should be compact. 0.97. What is the ratio of the CO2 emissions (% of total fuel combustion) of Dominican Republic in 1976 to that in 1977?
Provide a succinct answer. 1.04. What is the ratio of the CO2 emissions (% of total fuel combustion) in Honduras in 1976 to that in 1977?
Your response must be concise. 1.05. What is the ratio of the CO2 emissions (% of total fuel combustion) in Saudi Arabia in 1976 to that in 1977?
Offer a very short reply. 0.86. What is the ratio of the CO2 emissions (% of total fuel combustion) in Dominican Republic in 1976 to that in 1978?
Offer a terse response. 1.1. What is the ratio of the CO2 emissions (% of total fuel combustion) of Honduras in 1976 to that in 1978?
Offer a very short reply. 0.99. What is the ratio of the CO2 emissions (% of total fuel combustion) of Saudi Arabia in 1976 to that in 1978?
Your response must be concise. 0.78. What is the ratio of the CO2 emissions (% of total fuel combustion) in Spain in 1976 to that in 1978?
Your answer should be very brief. 0.92. What is the ratio of the CO2 emissions (% of total fuel combustion) of Dominican Republic in 1976 to that in 1979?
Make the answer very short. 1.08. What is the ratio of the CO2 emissions (% of total fuel combustion) of Saudi Arabia in 1976 to that in 1979?
Ensure brevity in your answer.  0.9. What is the ratio of the CO2 emissions (% of total fuel combustion) in Spain in 1976 to that in 1979?
Your answer should be very brief. 0.86. What is the ratio of the CO2 emissions (% of total fuel combustion) of Dominican Republic in 1976 to that in 1980?
Give a very brief answer. 1.2. What is the ratio of the CO2 emissions (% of total fuel combustion) of Honduras in 1976 to that in 1980?
Ensure brevity in your answer.  1.05. What is the ratio of the CO2 emissions (% of total fuel combustion) of Saudi Arabia in 1976 to that in 1980?
Offer a terse response. 1.38. What is the ratio of the CO2 emissions (% of total fuel combustion) in Spain in 1976 to that in 1980?
Make the answer very short. 0.96. What is the ratio of the CO2 emissions (% of total fuel combustion) in Dominican Republic in 1977 to that in 1978?
Your answer should be compact. 1.06. What is the ratio of the CO2 emissions (% of total fuel combustion) of Honduras in 1977 to that in 1978?
Your answer should be compact. 0.93. What is the ratio of the CO2 emissions (% of total fuel combustion) of Saudi Arabia in 1977 to that in 1978?
Provide a short and direct response. 0.9. What is the ratio of the CO2 emissions (% of total fuel combustion) of Spain in 1977 to that in 1978?
Provide a short and direct response. 0.94. What is the ratio of the CO2 emissions (% of total fuel combustion) of Dominican Republic in 1977 to that in 1979?
Offer a terse response. 1.03. What is the ratio of the CO2 emissions (% of total fuel combustion) of Honduras in 1977 to that in 1979?
Ensure brevity in your answer.  0.93. What is the ratio of the CO2 emissions (% of total fuel combustion) in Saudi Arabia in 1977 to that in 1979?
Ensure brevity in your answer.  1.04. What is the ratio of the CO2 emissions (% of total fuel combustion) in Spain in 1977 to that in 1979?
Offer a very short reply. 0.89. What is the ratio of the CO2 emissions (% of total fuel combustion) in Dominican Republic in 1977 to that in 1980?
Ensure brevity in your answer.  1.15. What is the ratio of the CO2 emissions (% of total fuel combustion) in Honduras in 1977 to that in 1980?
Your answer should be very brief. 1. What is the ratio of the CO2 emissions (% of total fuel combustion) of Saudi Arabia in 1977 to that in 1980?
Make the answer very short. 1.59. What is the ratio of the CO2 emissions (% of total fuel combustion) of Dominican Republic in 1978 to that in 1979?
Provide a succinct answer. 0.98. What is the ratio of the CO2 emissions (% of total fuel combustion) in Honduras in 1978 to that in 1979?
Your answer should be very brief. 1. What is the ratio of the CO2 emissions (% of total fuel combustion) in Saudi Arabia in 1978 to that in 1979?
Provide a succinct answer. 1.16. What is the ratio of the CO2 emissions (% of total fuel combustion) in Spain in 1978 to that in 1979?
Offer a very short reply. 0.94. What is the ratio of the CO2 emissions (% of total fuel combustion) of Dominican Republic in 1978 to that in 1980?
Offer a very short reply. 1.09. What is the ratio of the CO2 emissions (% of total fuel combustion) in Honduras in 1978 to that in 1980?
Offer a very short reply. 1.07. What is the ratio of the CO2 emissions (% of total fuel combustion) of Saudi Arabia in 1978 to that in 1980?
Keep it short and to the point. 1.77. What is the ratio of the CO2 emissions (% of total fuel combustion) in Spain in 1978 to that in 1980?
Ensure brevity in your answer.  1.04. What is the ratio of the CO2 emissions (% of total fuel combustion) of Dominican Republic in 1979 to that in 1980?
Offer a terse response. 1.11. What is the ratio of the CO2 emissions (% of total fuel combustion) in Honduras in 1979 to that in 1980?
Make the answer very short. 1.07. What is the ratio of the CO2 emissions (% of total fuel combustion) of Saudi Arabia in 1979 to that in 1980?
Offer a very short reply. 1.53. What is the ratio of the CO2 emissions (% of total fuel combustion) in Spain in 1979 to that in 1980?
Offer a very short reply. 1.11. What is the difference between the highest and the second highest CO2 emissions (% of total fuel combustion) in Dominican Republic?
Offer a very short reply. 0.25. What is the difference between the highest and the second highest CO2 emissions (% of total fuel combustion) in Honduras?
Keep it short and to the point. 0.47. What is the difference between the highest and the second highest CO2 emissions (% of total fuel combustion) in Saudi Arabia?
Your response must be concise. 3.56. What is the difference between the highest and the second highest CO2 emissions (% of total fuel combustion) in Spain?
Ensure brevity in your answer.  1.51. What is the difference between the highest and the lowest CO2 emissions (% of total fuel combustion) of Dominican Republic?
Provide a succinct answer. 5.54. What is the difference between the highest and the lowest CO2 emissions (% of total fuel combustion) of Honduras?
Your answer should be compact. 3.09. What is the difference between the highest and the lowest CO2 emissions (% of total fuel combustion) in Saudi Arabia?
Offer a terse response. 15.12. What is the difference between the highest and the lowest CO2 emissions (% of total fuel combustion) in Spain?
Make the answer very short. 3.55. 